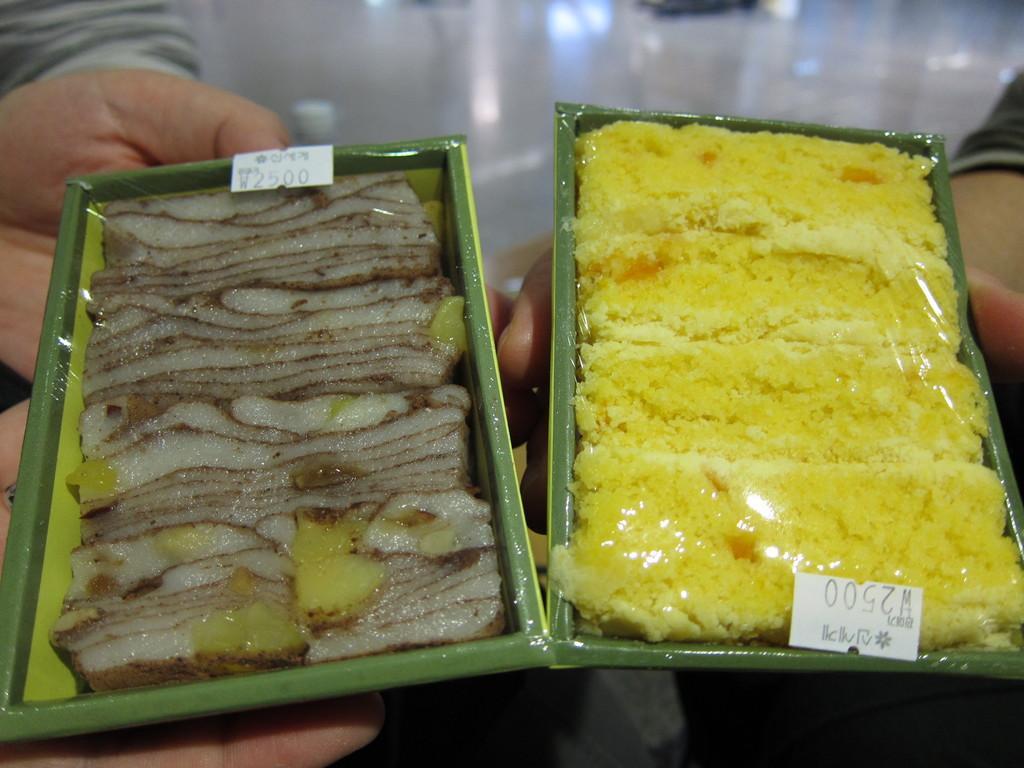Could you give a brief overview of what you see in this image? In this image I can see two rectangular food bowls with food I can see stickers on these bowls with some numbers and text. I can see hands beneath the boughs holding this bowls. 